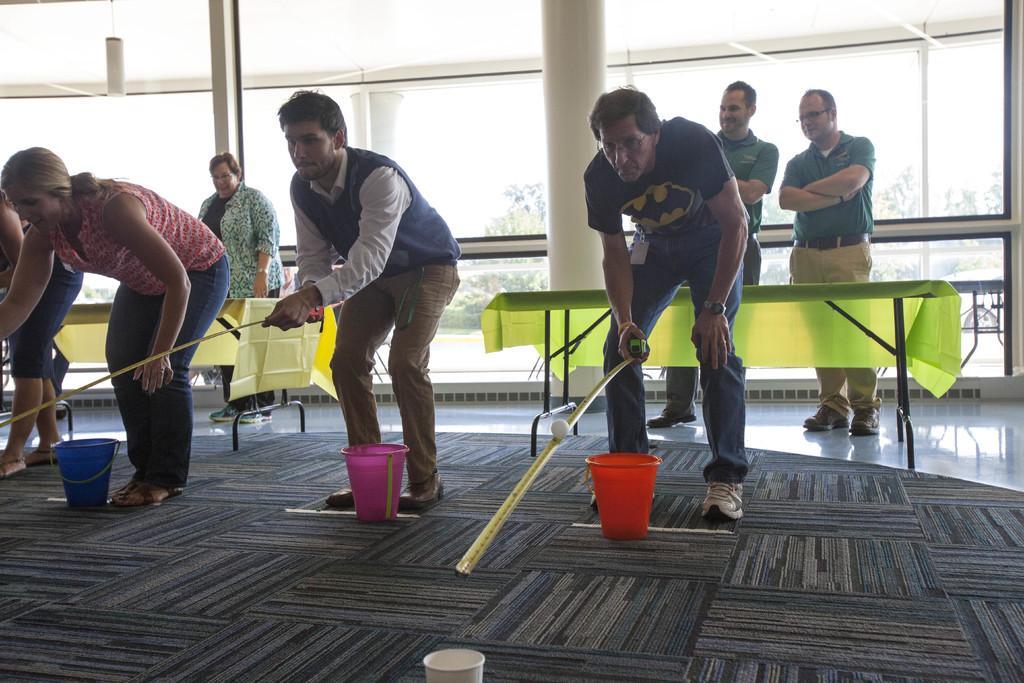How would you summarize this image in a sentence or two? In this image it seems like there are few people who are playing the game by holding a tape in their hands. On the tape there's a ball which has to fall in the cup which is in front of them. There is a bucket near the legs of the people who are playing. At the back side there is table and there are two people standing beside the table. And there is a glass window through which we can see the trees. At the bottom on the floor there is a carpet. 